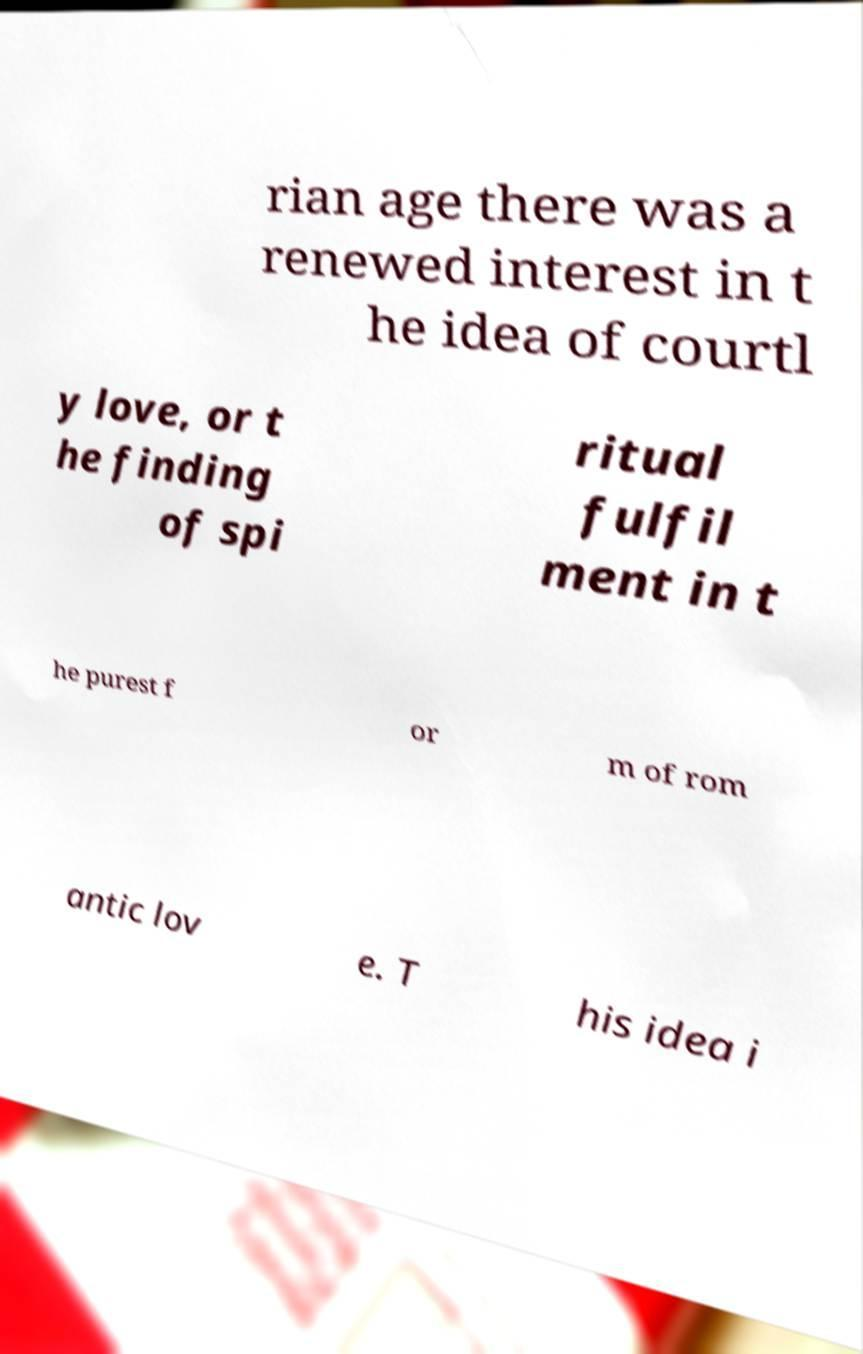Could you assist in decoding the text presented in this image and type it out clearly? rian age there was a renewed interest in t he idea of courtl y love, or t he finding of spi ritual fulfil ment in t he purest f or m of rom antic lov e. T his idea i 